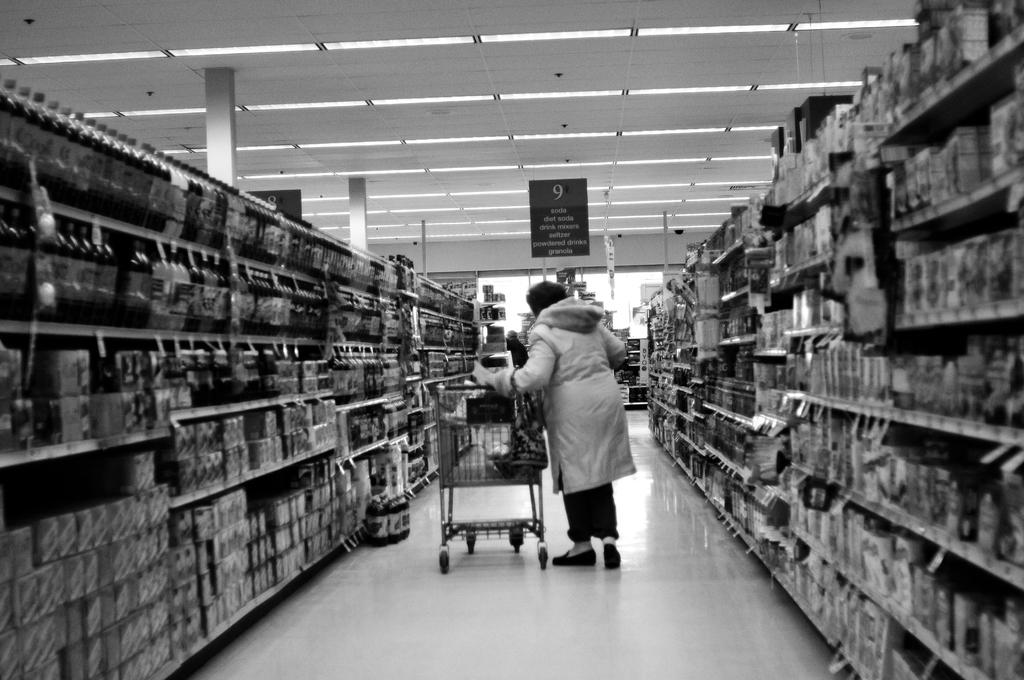<image>
Render a clear and concise summary of the photo. In a supermarket, a woman moves down aisle 9, which has soda, granola, and more. 